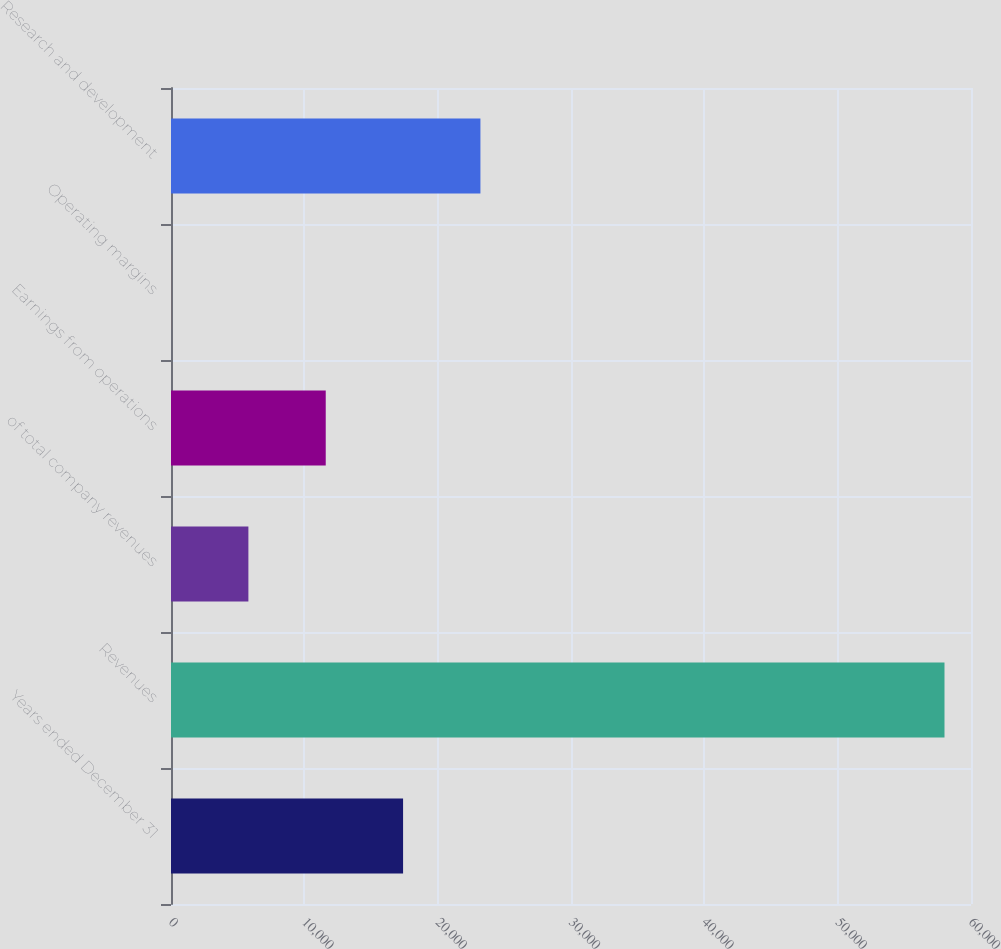<chart> <loc_0><loc_0><loc_500><loc_500><bar_chart><fcel>Years ended December 31<fcel>Revenues<fcel>of total company revenues<fcel>Earnings from operations<fcel>Operating margins<fcel>Research and development<nl><fcel>17406<fcel>58012<fcel>5804.26<fcel>11605.1<fcel>3.4<fcel>23206.8<nl></chart> 